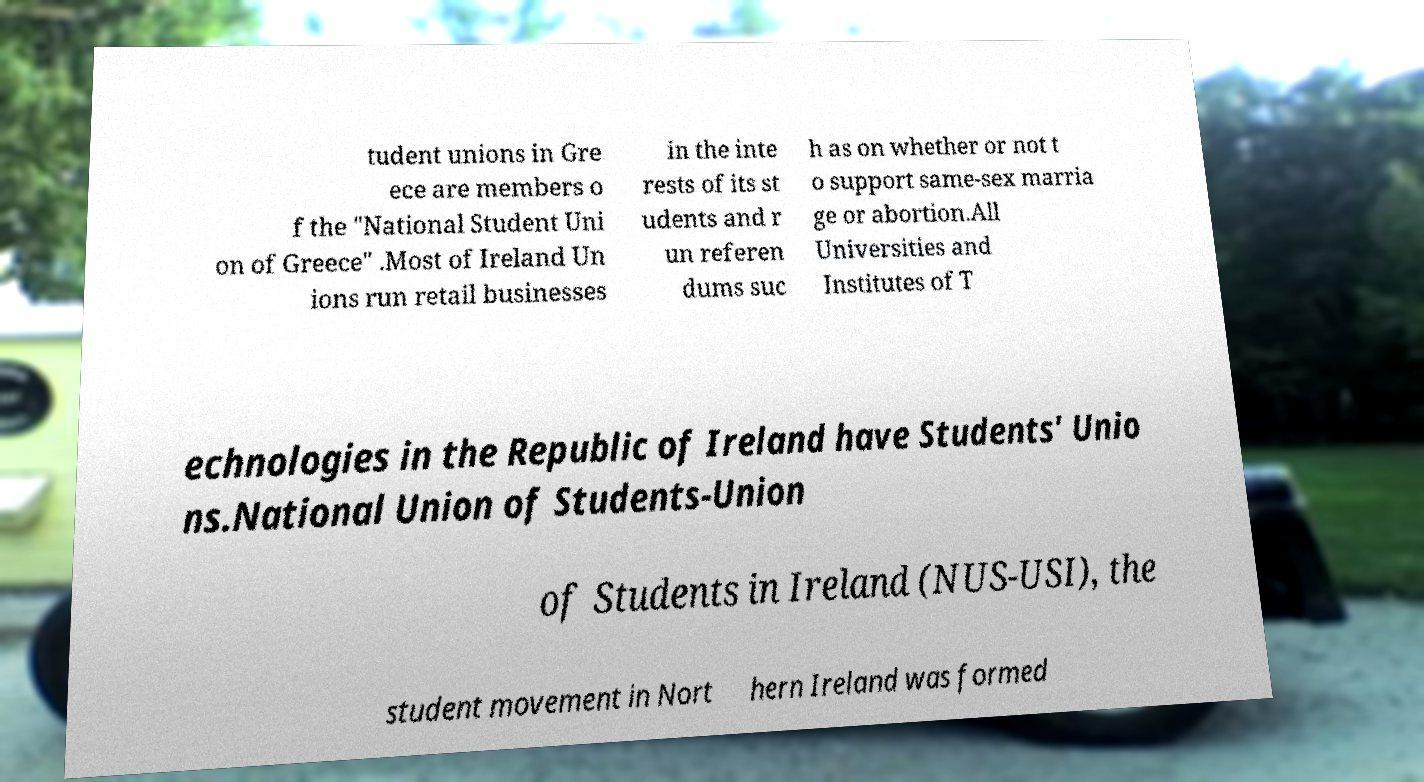Can you accurately transcribe the text from the provided image for me? tudent unions in Gre ece are members o f the "National Student Uni on of Greece" .Most of Ireland Un ions run retail businesses in the inte rests of its st udents and r un referen dums suc h as on whether or not t o support same-sex marria ge or abortion.All Universities and Institutes of T echnologies in the Republic of Ireland have Students' Unio ns.National Union of Students-Union of Students in Ireland (NUS-USI), the student movement in Nort hern Ireland was formed 